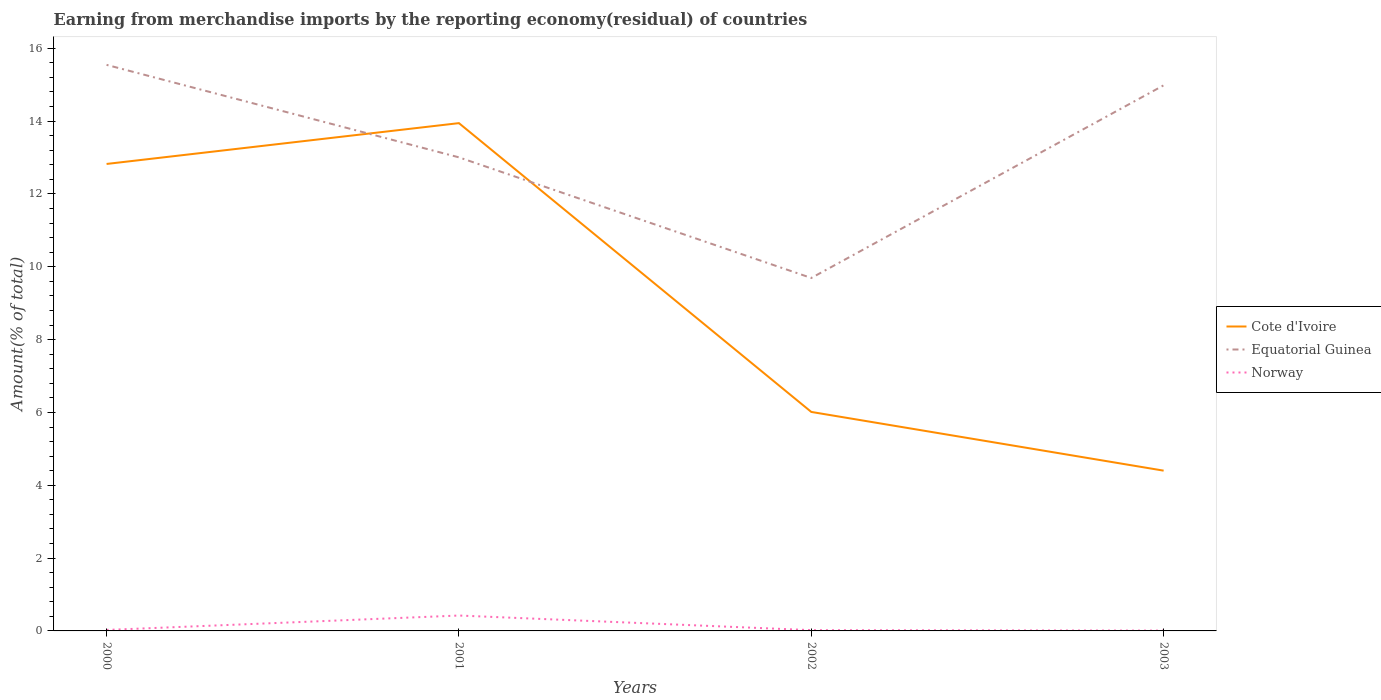Does the line corresponding to Norway intersect with the line corresponding to Cote d'Ivoire?
Offer a very short reply. No. Across all years, what is the maximum percentage of amount earned from merchandise imports in Cote d'Ivoire?
Your answer should be compact. 4.4. In which year was the percentage of amount earned from merchandise imports in Cote d'Ivoire maximum?
Provide a succinct answer. 2003. What is the total percentage of amount earned from merchandise imports in Cote d'Ivoire in the graph?
Offer a terse response. 9.54. What is the difference between the highest and the second highest percentage of amount earned from merchandise imports in Cote d'Ivoire?
Keep it short and to the point. 9.54. Is the percentage of amount earned from merchandise imports in Norway strictly greater than the percentage of amount earned from merchandise imports in Cote d'Ivoire over the years?
Make the answer very short. Yes. How many lines are there?
Your answer should be compact. 3. How many years are there in the graph?
Give a very brief answer. 4. What is the difference between two consecutive major ticks on the Y-axis?
Ensure brevity in your answer.  2. Are the values on the major ticks of Y-axis written in scientific E-notation?
Make the answer very short. No. Does the graph contain grids?
Provide a succinct answer. No. How are the legend labels stacked?
Provide a short and direct response. Vertical. What is the title of the graph?
Your answer should be compact. Earning from merchandise imports by the reporting economy(residual) of countries. What is the label or title of the X-axis?
Your answer should be very brief. Years. What is the label or title of the Y-axis?
Offer a terse response. Amount(% of total). What is the Amount(% of total) of Cote d'Ivoire in 2000?
Your response must be concise. 12.82. What is the Amount(% of total) in Equatorial Guinea in 2000?
Offer a very short reply. 15.55. What is the Amount(% of total) of Norway in 2000?
Your answer should be compact. 0.03. What is the Amount(% of total) in Cote d'Ivoire in 2001?
Provide a succinct answer. 13.94. What is the Amount(% of total) in Equatorial Guinea in 2001?
Your answer should be very brief. 13.01. What is the Amount(% of total) of Norway in 2001?
Your response must be concise. 0.42. What is the Amount(% of total) of Cote d'Ivoire in 2002?
Offer a terse response. 6.01. What is the Amount(% of total) in Equatorial Guinea in 2002?
Offer a very short reply. 9.69. What is the Amount(% of total) in Norway in 2002?
Keep it short and to the point. 0.02. What is the Amount(% of total) in Cote d'Ivoire in 2003?
Ensure brevity in your answer.  4.4. What is the Amount(% of total) in Equatorial Guinea in 2003?
Your answer should be very brief. 14.98. What is the Amount(% of total) of Norway in 2003?
Provide a short and direct response. 0.01. Across all years, what is the maximum Amount(% of total) of Cote d'Ivoire?
Make the answer very short. 13.94. Across all years, what is the maximum Amount(% of total) in Equatorial Guinea?
Offer a terse response. 15.55. Across all years, what is the maximum Amount(% of total) in Norway?
Provide a short and direct response. 0.42. Across all years, what is the minimum Amount(% of total) of Cote d'Ivoire?
Give a very brief answer. 4.4. Across all years, what is the minimum Amount(% of total) of Equatorial Guinea?
Offer a very short reply. 9.69. Across all years, what is the minimum Amount(% of total) of Norway?
Provide a short and direct response. 0.01. What is the total Amount(% of total) in Cote d'Ivoire in the graph?
Make the answer very short. 37.18. What is the total Amount(% of total) of Equatorial Guinea in the graph?
Offer a very short reply. 53.23. What is the total Amount(% of total) of Norway in the graph?
Make the answer very short. 0.48. What is the difference between the Amount(% of total) in Cote d'Ivoire in 2000 and that in 2001?
Provide a succinct answer. -1.12. What is the difference between the Amount(% of total) of Equatorial Guinea in 2000 and that in 2001?
Ensure brevity in your answer.  2.54. What is the difference between the Amount(% of total) of Norway in 2000 and that in 2001?
Your answer should be very brief. -0.4. What is the difference between the Amount(% of total) in Cote d'Ivoire in 2000 and that in 2002?
Your response must be concise. 6.81. What is the difference between the Amount(% of total) of Equatorial Guinea in 2000 and that in 2002?
Provide a short and direct response. 5.85. What is the difference between the Amount(% of total) of Norway in 2000 and that in 2002?
Your answer should be very brief. 0.01. What is the difference between the Amount(% of total) in Cote d'Ivoire in 2000 and that in 2003?
Keep it short and to the point. 8.42. What is the difference between the Amount(% of total) in Equatorial Guinea in 2000 and that in 2003?
Your answer should be very brief. 0.56. What is the difference between the Amount(% of total) of Norway in 2000 and that in 2003?
Provide a short and direct response. 0.02. What is the difference between the Amount(% of total) of Cote d'Ivoire in 2001 and that in 2002?
Your answer should be very brief. 7.93. What is the difference between the Amount(% of total) of Equatorial Guinea in 2001 and that in 2002?
Keep it short and to the point. 3.31. What is the difference between the Amount(% of total) in Norway in 2001 and that in 2002?
Provide a short and direct response. 0.4. What is the difference between the Amount(% of total) of Cote d'Ivoire in 2001 and that in 2003?
Your answer should be compact. 9.54. What is the difference between the Amount(% of total) in Equatorial Guinea in 2001 and that in 2003?
Make the answer very short. -1.98. What is the difference between the Amount(% of total) of Norway in 2001 and that in 2003?
Your answer should be compact. 0.41. What is the difference between the Amount(% of total) in Cote d'Ivoire in 2002 and that in 2003?
Keep it short and to the point. 1.61. What is the difference between the Amount(% of total) in Equatorial Guinea in 2002 and that in 2003?
Offer a terse response. -5.29. What is the difference between the Amount(% of total) of Norway in 2002 and that in 2003?
Make the answer very short. 0.01. What is the difference between the Amount(% of total) of Cote d'Ivoire in 2000 and the Amount(% of total) of Equatorial Guinea in 2001?
Provide a short and direct response. -0.18. What is the difference between the Amount(% of total) in Cote d'Ivoire in 2000 and the Amount(% of total) in Norway in 2001?
Your answer should be compact. 12.4. What is the difference between the Amount(% of total) in Equatorial Guinea in 2000 and the Amount(% of total) in Norway in 2001?
Provide a succinct answer. 15.12. What is the difference between the Amount(% of total) in Cote d'Ivoire in 2000 and the Amount(% of total) in Equatorial Guinea in 2002?
Provide a succinct answer. 3.13. What is the difference between the Amount(% of total) of Cote d'Ivoire in 2000 and the Amount(% of total) of Norway in 2002?
Provide a short and direct response. 12.8. What is the difference between the Amount(% of total) of Equatorial Guinea in 2000 and the Amount(% of total) of Norway in 2002?
Ensure brevity in your answer.  15.52. What is the difference between the Amount(% of total) of Cote d'Ivoire in 2000 and the Amount(% of total) of Equatorial Guinea in 2003?
Ensure brevity in your answer.  -2.16. What is the difference between the Amount(% of total) in Cote d'Ivoire in 2000 and the Amount(% of total) in Norway in 2003?
Keep it short and to the point. 12.82. What is the difference between the Amount(% of total) of Equatorial Guinea in 2000 and the Amount(% of total) of Norway in 2003?
Provide a short and direct response. 15.54. What is the difference between the Amount(% of total) in Cote d'Ivoire in 2001 and the Amount(% of total) in Equatorial Guinea in 2002?
Your answer should be compact. 4.25. What is the difference between the Amount(% of total) in Cote d'Ivoire in 2001 and the Amount(% of total) in Norway in 2002?
Offer a very short reply. 13.92. What is the difference between the Amount(% of total) of Equatorial Guinea in 2001 and the Amount(% of total) of Norway in 2002?
Keep it short and to the point. 12.98. What is the difference between the Amount(% of total) of Cote d'Ivoire in 2001 and the Amount(% of total) of Equatorial Guinea in 2003?
Keep it short and to the point. -1.04. What is the difference between the Amount(% of total) of Cote d'Ivoire in 2001 and the Amount(% of total) of Norway in 2003?
Offer a terse response. 13.94. What is the difference between the Amount(% of total) of Equatorial Guinea in 2001 and the Amount(% of total) of Norway in 2003?
Your answer should be compact. 13. What is the difference between the Amount(% of total) of Cote d'Ivoire in 2002 and the Amount(% of total) of Equatorial Guinea in 2003?
Make the answer very short. -8.97. What is the difference between the Amount(% of total) of Cote d'Ivoire in 2002 and the Amount(% of total) of Norway in 2003?
Give a very brief answer. 6.01. What is the difference between the Amount(% of total) in Equatorial Guinea in 2002 and the Amount(% of total) in Norway in 2003?
Your answer should be compact. 9.68. What is the average Amount(% of total) in Cote d'Ivoire per year?
Ensure brevity in your answer.  9.3. What is the average Amount(% of total) in Equatorial Guinea per year?
Your answer should be compact. 13.31. What is the average Amount(% of total) of Norway per year?
Keep it short and to the point. 0.12. In the year 2000, what is the difference between the Amount(% of total) in Cote d'Ivoire and Amount(% of total) in Equatorial Guinea?
Your answer should be compact. -2.72. In the year 2000, what is the difference between the Amount(% of total) in Cote d'Ivoire and Amount(% of total) in Norway?
Make the answer very short. 12.8. In the year 2000, what is the difference between the Amount(% of total) of Equatorial Guinea and Amount(% of total) of Norway?
Provide a succinct answer. 15.52. In the year 2001, what is the difference between the Amount(% of total) of Cote d'Ivoire and Amount(% of total) of Equatorial Guinea?
Keep it short and to the point. 0.94. In the year 2001, what is the difference between the Amount(% of total) in Cote d'Ivoire and Amount(% of total) in Norway?
Keep it short and to the point. 13.52. In the year 2001, what is the difference between the Amount(% of total) in Equatorial Guinea and Amount(% of total) in Norway?
Offer a very short reply. 12.58. In the year 2002, what is the difference between the Amount(% of total) in Cote d'Ivoire and Amount(% of total) in Equatorial Guinea?
Your answer should be very brief. -3.68. In the year 2002, what is the difference between the Amount(% of total) in Cote d'Ivoire and Amount(% of total) in Norway?
Offer a terse response. 5.99. In the year 2002, what is the difference between the Amount(% of total) in Equatorial Guinea and Amount(% of total) in Norway?
Provide a short and direct response. 9.67. In the year 2003, what is the difference between the Amount(% of total) in Cote d'Ivoire and Amount(% of total) in Equatorial Guinea?
Offer a very short reply. -10.58. In the year 2003, what is the difference between the Amount(% of total) in Cote d'Ivoire and Amount(% of total) in Norway?
Make the answer very short. 4.39. In the year 2003, what is the difference between the Amount(% of total) of Equatorial Guinea and Amount(% of total) of Norway?
Make the answer very short. 14.97. What is the ratio of the Amount(% of total) in Cote d'Ivoire in 2000 to that in 2001?
Your answer should be very brief. 0.92. What is the ratio of the Amount(% of total) of Equatorial Guinea in 2000 to that in 2001?
Give a very brief answer. 1.2. What is the ratio of the Amount(% of total) in Norway in 2000 to that in 2001?
Ensure brevity in your answer.  0.06. What is the ratio of the Amount(% of total) of Cote d'Ivoire in 2000 to that in 2002?
Your answer should be compact. 2.13. What is the ratio of the Amount(% of total) of Equatorial Guinea in 2000 to that in 2002?
Offer a terse response. 1.6. What is the ratio of the Amount(% of total) of Norway in 2000 to that in 2002?
Make the answer very short. 1.28. What is the ratio of the Amount(% of total) in Cote d'Ivoire in 2000 to that in 2003?
Provide a succinct answer. 2.91. What is the ratio of the Amount(% of total) of Equatorial Guinea in 2000 to that in 2003?
Keep it short and to the point. 1.04. What is the ratio of the Amount(% of total) in Norway in 2000 to that in 2003?
Offer a terse response. 3.04. What is the ratio of the Amount(% of total) of Cote d'Ivoire in 2001 to that in 2002?
Ensure brevity in your answer.  2.32. What is the ratio of the Amount(% of total) in Equatorial Guinea in 2001 to that in 2002?
Keep it short and to the point. 1.34. What is the ratio of the Amount(% of total) of Norway in 2001 to that in 2002?
Give a very brief answer. 20.2. What is the ratio of the Amount(% of total) in Cote d'Ivoire in 2001 to that in 2003?
Ensure brevity in your answer.  3.17. What is the ratio of the Amount(% of total) in Equatorial Guinea in 2001 to that in 2003?
Your response must be concise. 0.87. What is the ratio of the Amount(% of total) of Norway in 2001 to that in 2003?
Provide a short and direct response. 47.99. What is the ratio of the Amount(% of total) in Cote d'Ivoire in 2002 to that in 2003?
Make the answer very short. 1.37. What is the ratio of the Amount(% of total) in Equatorial Guinea in 2002 to that in 2003?
Give a very brief answer. 0.65. What is the ratio of the Amount(% of total) of Norway in 2002 to that in 2003?
Keep it short and to the point. 2.38. What is the difference between the highest and the second highest Amount(% of total) in Cote d'Ivoire?
Keep it short and to the point. 1.12. What is the difference between the highest and the second highest Amount(% of total) of Equatorial Guinea?
Offer a terse response. 0.56. What is the difference between the highest and the second highest Amount(% of total) in Norway?
Your response must be concise. 0.4. What is the difference between the highest and the lowest Amount(% of total) of Cote d'Ivoire?
Provide a short and direct response. 9.54. What is the difference between the highest and the lowest Amount(% of total) in Equatorial Guinea?
Your answer should be compact. 5.85. What is the difference between the highest and the lowest Amount(% of total) in Norway?
Make the answer very short. 0.41. 